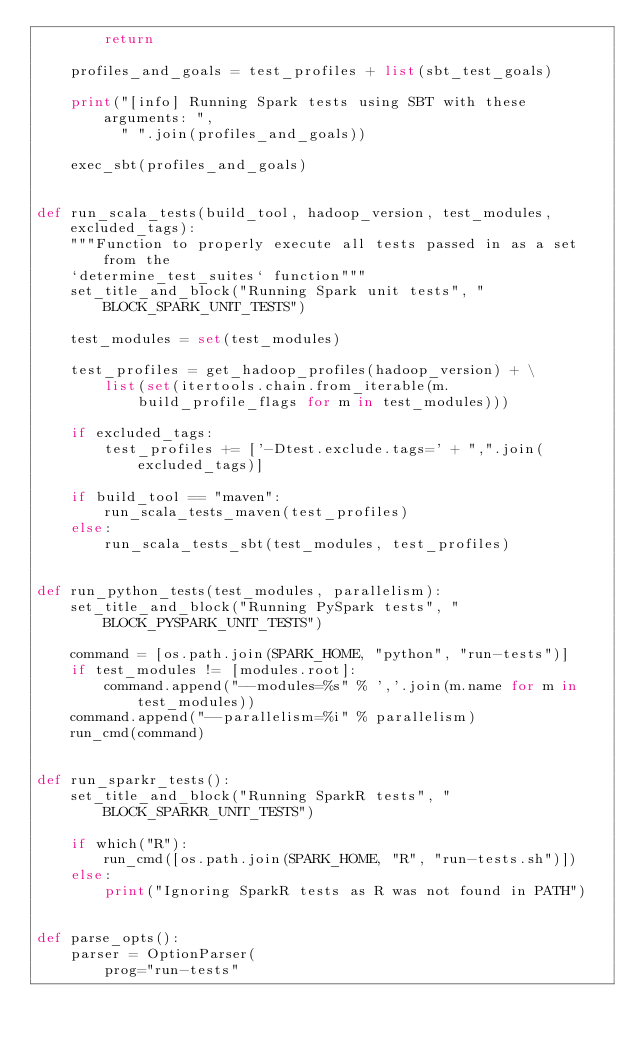Convert code to text. <code><loc_0><loc_0><loc_500><loc_500><_Python_>        return

    profiles_and_goals = test_profiles + list(sbt_test_goals)

    print("[info] Running Spark tests using SBT with these arguments: ",
          " ".join(profiles_and_goals))

    exec_sbt(profiles_and_goals)


def run_scala_tests(build_tool, hadoop_version, test_modules, excluded_tags):
    """Function to properly execute all tests passed in as a set from the
    `determine_test_suites` function"""
    set_title_and_block("Running Spark unit tests", "BLOCK_SPARK_UNIT_TESTS")

    test_modules = set(test_modules)

    test_profiles = get_hadoop_profiles(hadoop_version) + \
        list(set(itertools.chain.from_iterable(m.build_profile_flags for m in test_modules)))

    if excluded_tags:
        test_profiles += ['-Dtest.exclude.tags=' + ",".join(excluded_tags)]

    if build_tool == "maven":
        run_scala_tests_maven(test_profiles)
    else:
        run_scala_tests_sbt(test_modules, test_profiles)


def run_python_tests(test_modules, parallelism):
    set_title_and_block("Running PySpark tests", "BLOCK_PYSPARK_UNIT_TESTS")

    command = [os.path.join(SPARK_HOME, "python", "run-tests")]
    if test_modules != [modules.root]:
        command.append("--modules=%s" % ','.join(m.name for m in test_modules))
    command.append("--parallelism=%i" % parallelism)
    run_cmd(command)


def run_sparkr_tests():
    set_title_and_block("Running SparkR tests", "BLOCK_SPARKR_UNIT_TESTS")

    if which("R"):
        run_cmd([os.path.join(SPARK_HOME, "R", "run-tests.sh")])
    else:
        print("Ignoring SparkR tests as R was not found in PATH")


def parse_opts():
    parser = OptionParser(
        prog="run-tests"</code> 